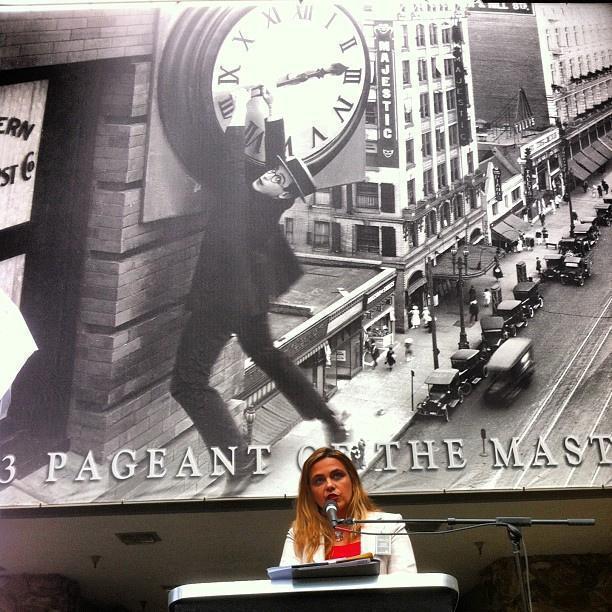What is this movie most likely to be?
Indicate the correct response by choosing from the four available options to answer the question.
Options: Horror, comedy, action, history. Comedy. 